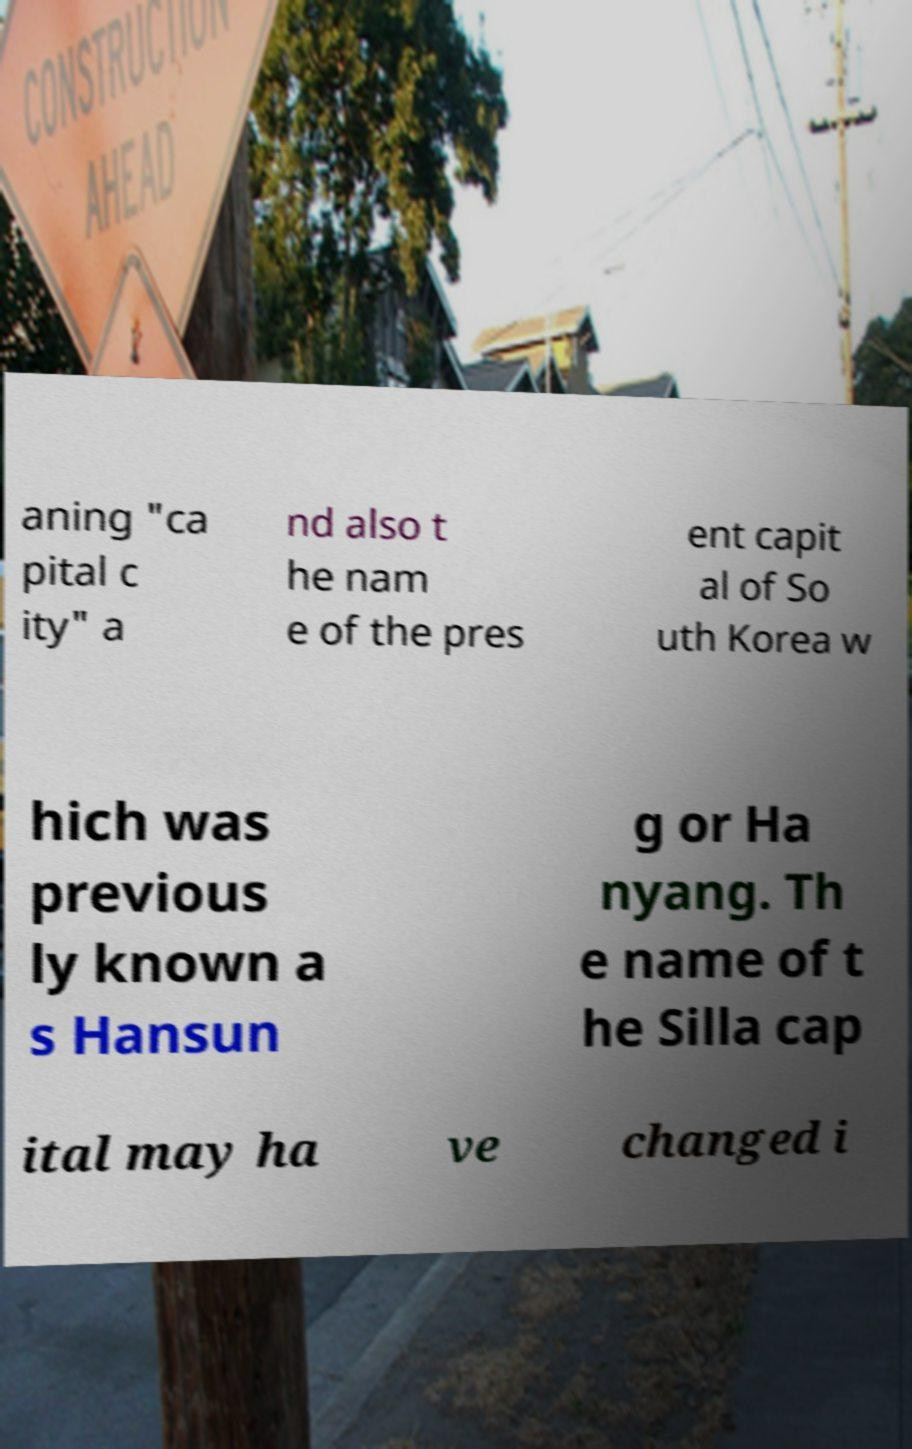Please identify and transcribe the text found in this image. aning "ca pital c ity" a nd also t he nam e of the pres ent capit al of So uth Korea w hich was previous ly known a s Hansun g or Ha nyang. Th e name of t he Silla cap ital may ha ve changed i 